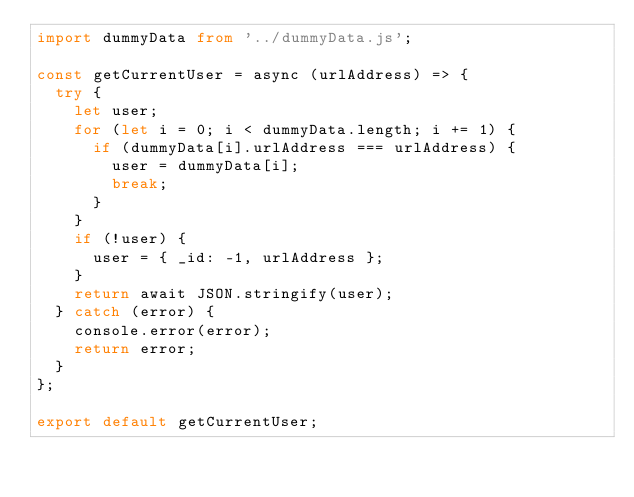<code> <loc_0><loc_0><loc_500><loc_500><_TypeScript_>import dummyData from '../dummyData.js';

const getCurrentUser = async (urlAddress) => {
  try {
    let user;
    for (let i = 0; i < dummyData.length; i += 1) {
      if (dummyData[i].urlAddress === urlAddress) {
        user = dummyData[i];
        break;
      }
    }
    if (!user) {
      user = { _id: -1, urlAddress };
    }
    return await JSON.stringify(user);
  } catch (error) {
    console.error(error);
    return error;
  }
};

export default getCurrentUser;
</code> 